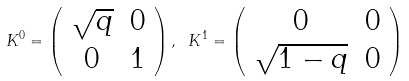<formula> <loc_0><loc_0><loc_500><loc_500>K ^ { 0 } = \left ( \begin{array} { c c } \sqrt { q } & 0 \\ 0 & 1 \end{array} \right ) , \ K ^ { 1 } = \left ( \begin{array} { c c } 0 & 0 \\ \sqrt { 1 - q } & 0 \end{array} \right )</formula> 